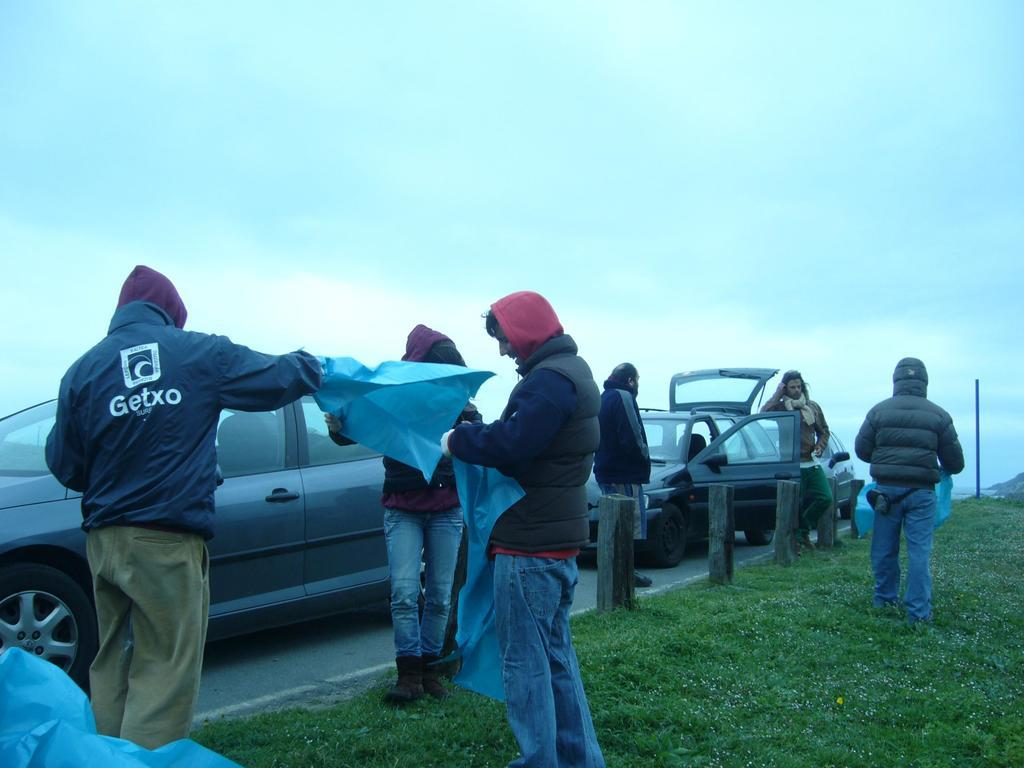What can be seen in the background of the image? The sky is visible in the background of the image. What type of vehicles are in the image? There are cars in the image. What is the main surface in the image? There is a road in the image. What type of structures are in the image? There are poles in the image. What type of vegetation is present in the image? Green grass is present in the image. What are some people doing in the image? Some people are holding blue cover sheets. Can you tell me how many beggars are visible in the image? There are no beggars present in the image. What type of box is being used to store the notes in the image? There are no notes or boxes present in the image. 